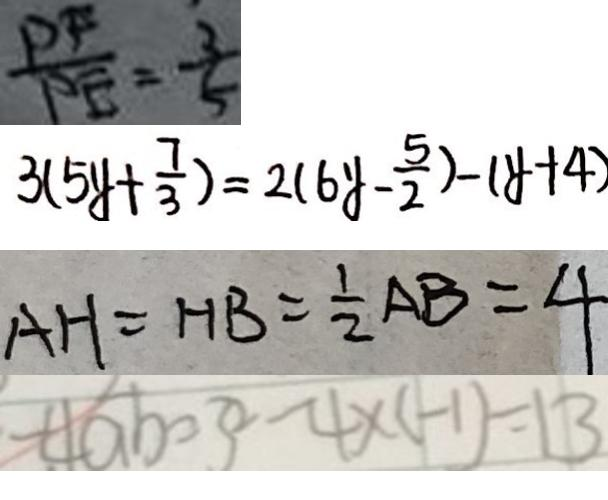Convert formula to latex. <formula><loc_0><loc_0><loc_500><loc_500>\frac { P F } { P E } = \frac { 3 } { 5 } 
 3 ( 5 y + \frac { 7 } { 3 } ) = 2 ( 6 y - \frac { 5 } { 2 } ) - ( y + 4 ) 
 A H = H B = \frac { 1 } { 2 } A B = 4 
 - 4 a b = 3 ^ { 2 } - 4 \times ( - 1 ) = 1 3</formula> 